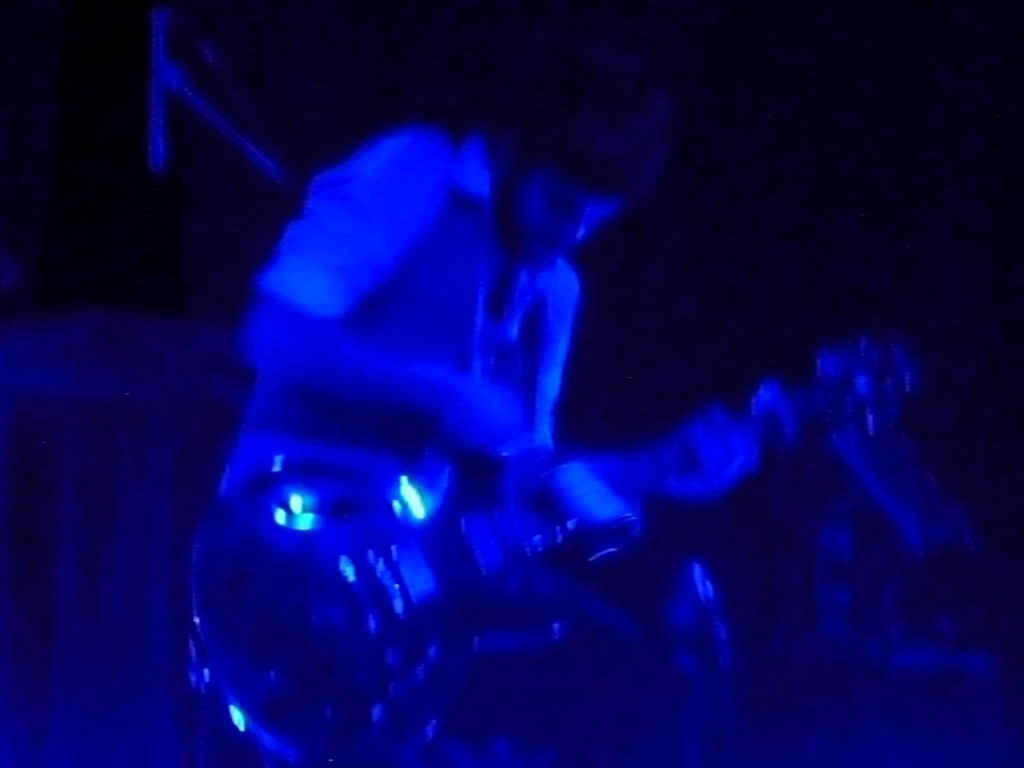This image appears to capture a musical performance. Can you describe the atmosphere suggested by the lighting? The deep blue hues and the blurred motion of the subject imply a dynamic and intensely charged atmosphere, often associated with live music events. The usage of such dominant cool lighting can evoke a sense of energy, focus, and depth, resonating with the rhythm and passion of a performance. 